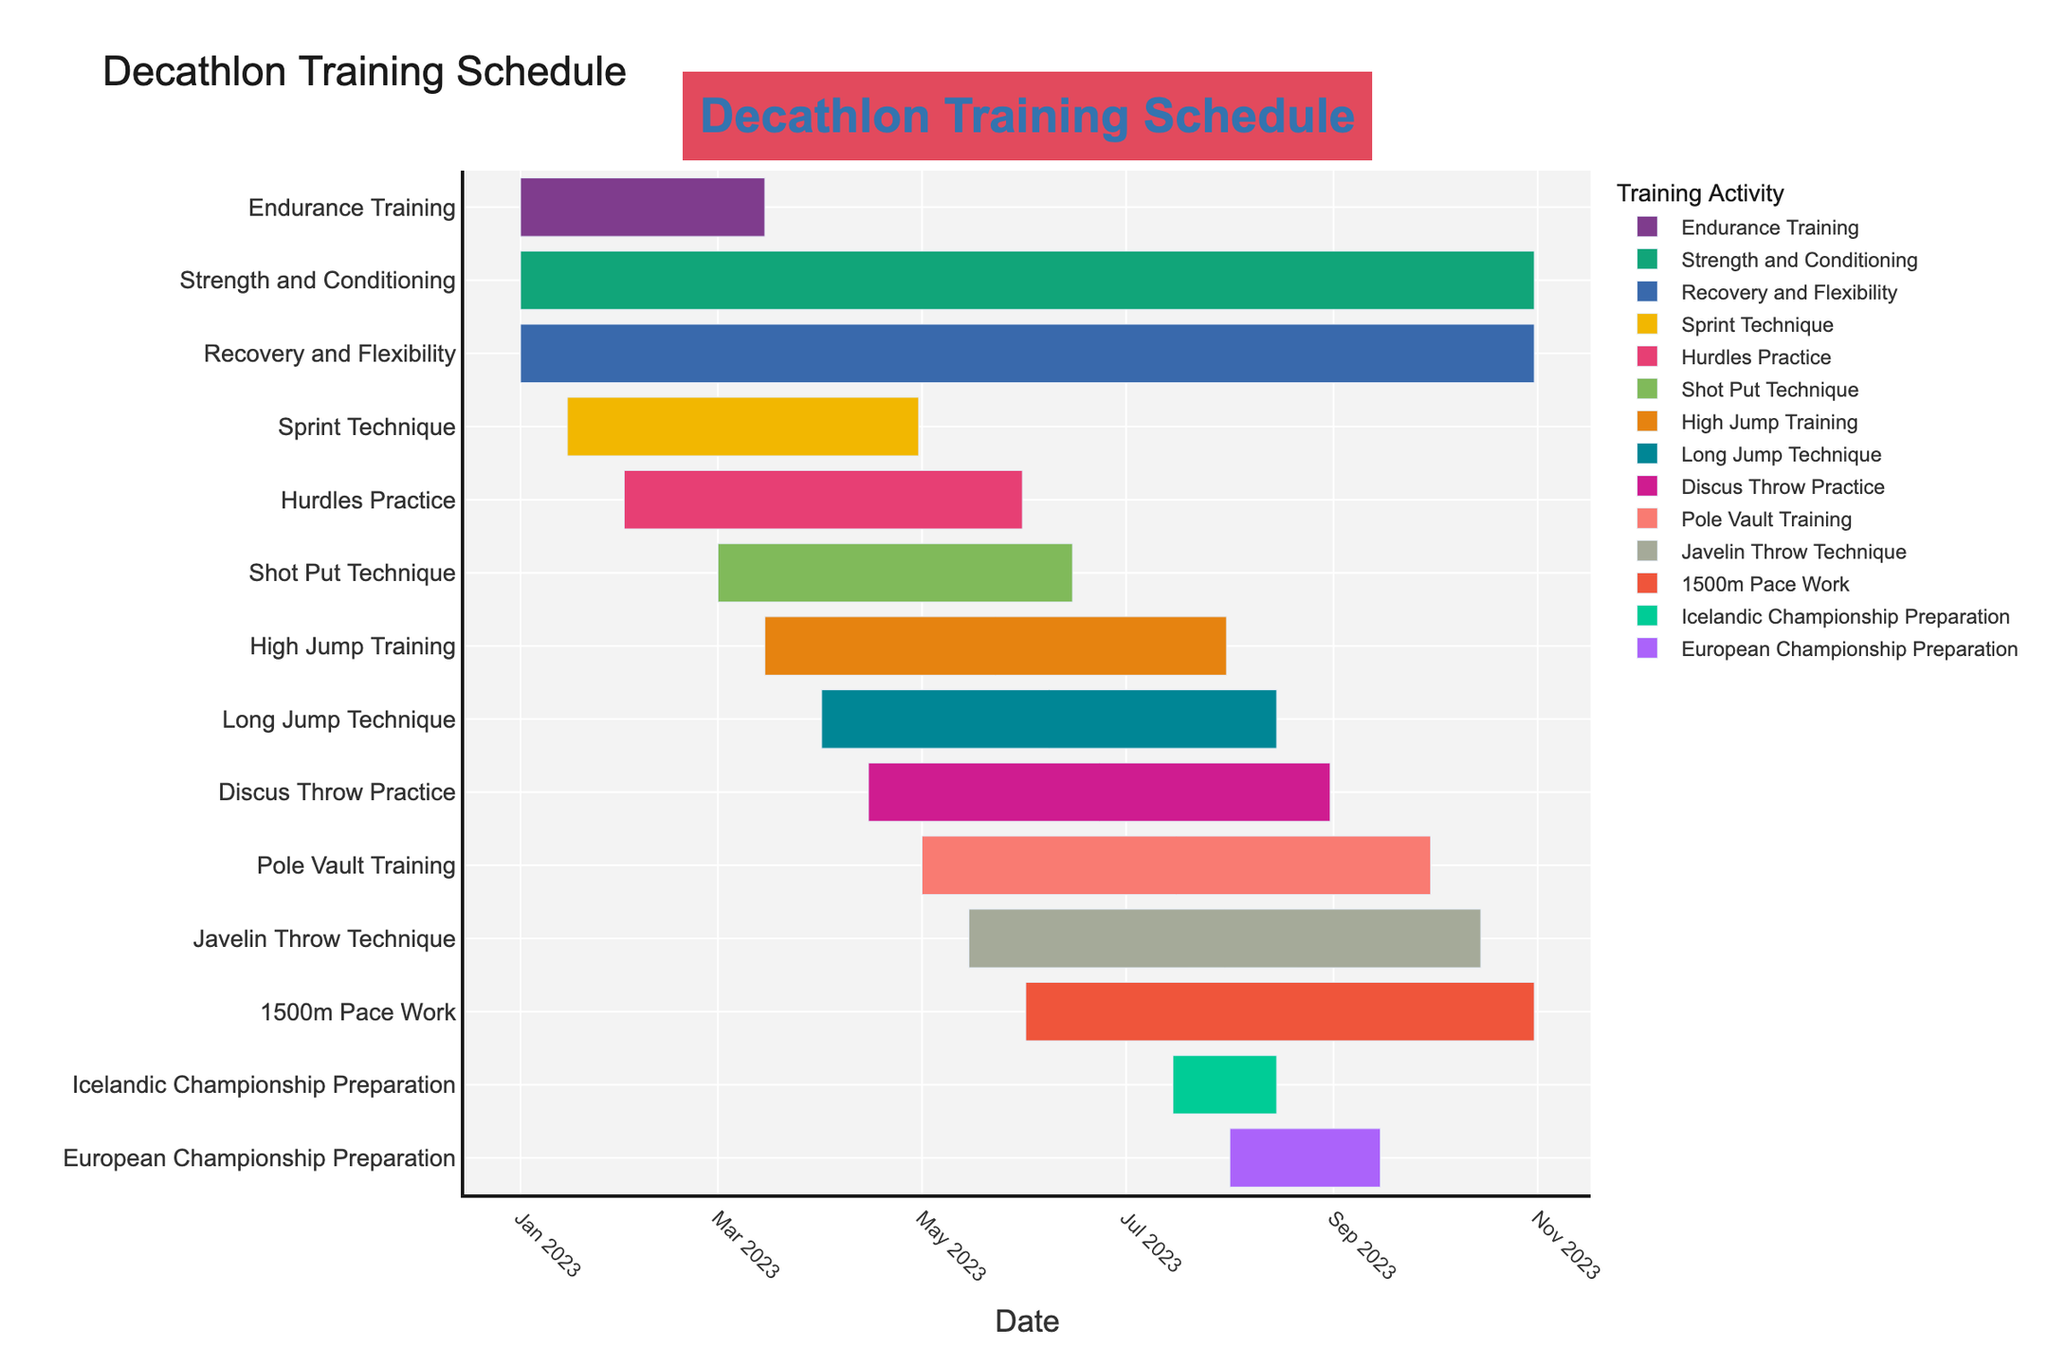What's the title of the Gantt Chart? The title of the chart is prominently displayed at the top. It reads "Decathlon Training Schedule" with specific colors that represent the Icelandic flag.
Answer: Decathlon Training Schedule When do the Endurance Training sessions start and end? The chart indicates the start and end dates for different tasks. For Endurance Training, it starts on January 1, 2023, and ends on March 15, 2023.
Answer: January 1, 2023, to March 15, 2023 Which training activities are scheduled for the entire year? The activities covering the entire year are shown with long bars extending from January to October. Strength and Conditioning and Recovery and Flexibility both start on January 1, 2023, and end on October 31, 2023.
Answer: Strength and Conditioning, Recovery and Flexibility What is the duration of Hurdles Practice sessions? The start and end dates for Hurdles Practice are February 1, 2023, and May 31, 2023, respectively. The duration can be calculated by subtracting the start date from the end date.
Answer: 119 days Which exercise starts last in the season? By examining the chart, the last exercise to start is European Championship Preparation, which begins on August 1, 2023.
Answer: European Championship Preparation How does the duration of Shot Put Technique compare with High Jump Training? Shot Put Technique runs from March 1, 2023, to June 15, 2023, while High Jump Training runs from March 15, 2023, to July 31, 2023. Calculating the duration of both, Shot Put Technique has 106 days and High Jump Training has 139 days. High Jump Training is longer.
Answer: High Jump Training is longer Which exercise overlaps with the Icelandic Championship Preparation? The Icelandic Championship Preparation runs from July 15, 2023, to August 15, 2023. Exercises overlapping this period include High Jump Training, Long Jump Technique, Discus Throw Practice, Pole Vault Training, Javelin Throw Technique, 1500m Pace Work, Strength and Conditioning, and Recovery and Flexibility.
Answer: High Jump Training, Long Jump Technique, Discus Throw Practice, Pole Vault Training, Javelin Throw Technique, 1500m Pace Work, Strength and Conditioning, Recovery and Flexibility What is the total number of training activities, excluding championship preparations? Counting all the entries in the chart excluding Icelandic Championship Preparation and European Championship Preparation, there are 10 training activities.
Answer: 10 activities Which activity takes place between March and April only? By examining the March and April time frame, no activities begin and end entirely within these months. All activities during this period either start earlier or end later.
Answer: None How many activities are scheduled after May 1, 2023? Examining the start times of the activities after May 1, 2023, we have Pole Vault Training, Javelin Throw Technique, 1500m Pace Work, Strength and Conditioning, Recovery and Flexibility, Icelandic Championship Preparation, and European Championship Preparation. This totals to 7 activities.
Answer: 7 activities 